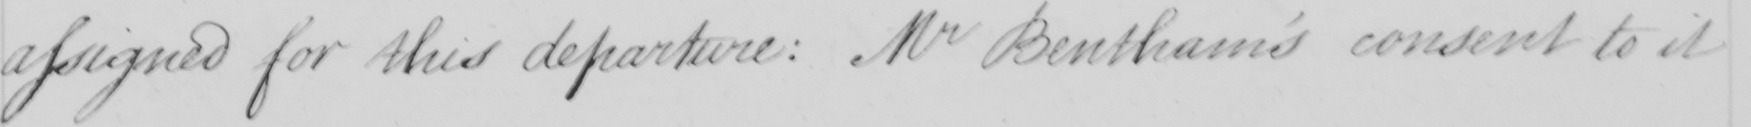Can you tell me what this handwritten text says? assigned for this departure: Mr Bentham's consent to it 